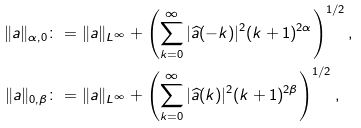<formula> <loc_0><loc_0><loc_500><loc_500>\| a \| _ { \alpha , 0 } & \colon = \| a \| _ { L ^ { \infty } } + \left ( \sum _ { k = 0 } ^ { \infty } | \widehat { a } ( - k ) | ^ { 2 } ( k + 1 ) ^ { 2 \alpha } \right ) ^ { 1 / 2 } , \\ \| a \| _ { 0 , \beta } & \colon = \| a \| _ { L ^ { \infty } } + \left ( \sum _ { k = 0 } ^ { \infty } | \widehat { a } ( k ) | ^ { 2 } ( k + 1 ) ^ { 2 \beta } \right ) ^ { 1 / 2 } ,</formula> 